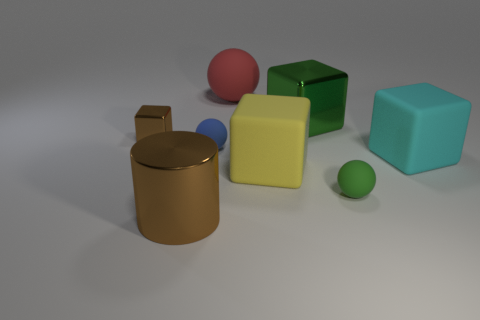What is the color of the big thing that is on the right side of the tiny thing on the right side of the tiny blue matte ball?
Provide a short and direct response. Cyan. Are there fewer big blocks than red rubber things?
Your answer should be compact. No. What number of brown things have the same shape as the tiny green thing?
Offer a very short reply. 0. What is the color of the other ball that is the same size as the blue matte ball?
Provide a succinct answer. Green. Are there the same number of blue rubber balls left of the tiny block and large cubes that are behind the cyan thing?
Ensure brevity in your answer.  No. Are there any spheres of the same size as the brown metallic cylinder?
Keep it short and to the point. Yes. What is the size of the brown metallic cylinder?
Provide a short and direct response. Large. Is the number of blue spheres to the left of the brown metallic cylinder the same as the number of small red matte spheres?
Your answer should be very brief. Yes. How many other objects are there of the same color as the small cube?
Offer a very short reply. 1. What color is the matte sphere that is both on the right side of the small blue object and in front of the large red sphere?
Provide a short and direct response. Green. 